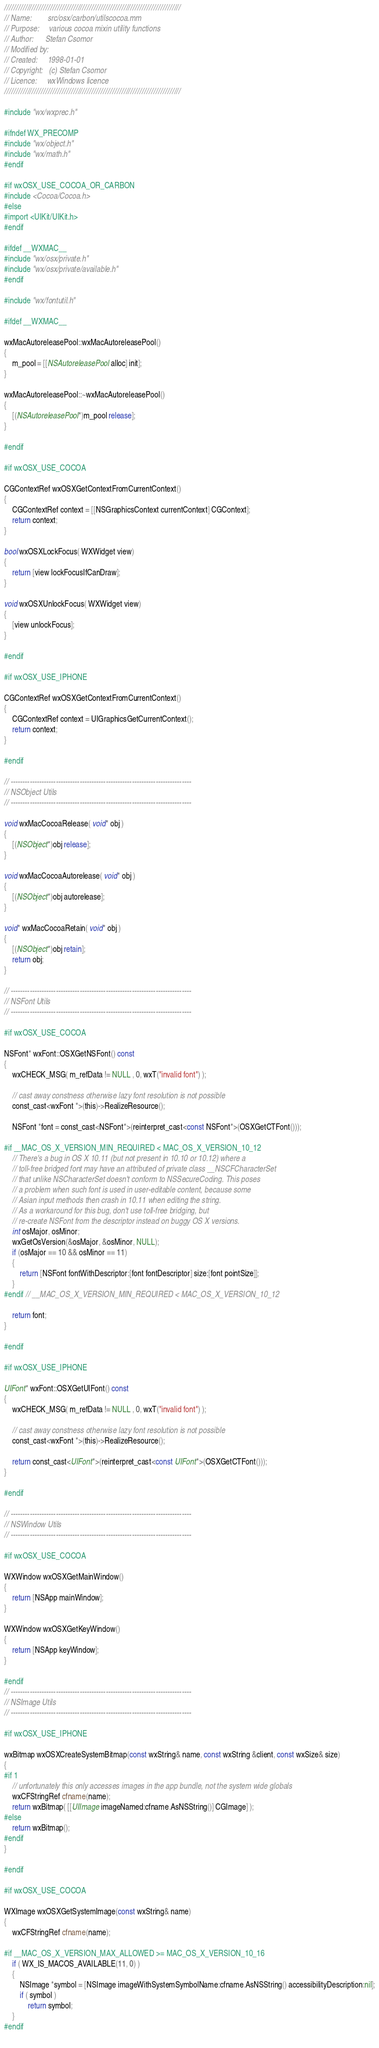<code> <loc_0><loc_0><loc_500><loc_500><_ObjectiveC_>/////////////////////////////////////////////////////////////////////////////
// Name:        src/osx/carbon/utilscocoa.mm
// Purpose:     various cocoa mixin utility functions
// Author:      Stefan Csomor
// Modified by:
// Created:     1998-01-01
// Copyright:   (c) Stefan Csomor
// Licence:     wxWindows licence
/////////////////////////////////////////////////////////////////////////////

#include "wx/wxprec.h"

#ifndef WX_PRECOMP
#include "wx/object.h"
#include "wx/math.h"
#endif

#if wxOSX_USE_COCOA_OR_CARBON
#include <Cocoa/Cocoa.h>
#else
#import <UIKit/UIKit.h>
#endif

#ifdef __WXMAC__
#include "wx/osx/private.h"
#include "wx/osx/private/available.h"
#endif

#include "wx/fontutil.h"

#ifdef __WXMAC__

wxMacAutoreleasePool::wxMacAutoreleasePool()
{
    m_pool = [[NSAutoreleasePool alloc] init];
}

wxMacAutoreleasePool::~wxMacAutoreleasePool()
{
    [(NSAutoreleasePool*)m_pool release];
}

#endif

#if wxOSX_USE_COCOA

CGContextRef wxOSXGetContextFromCurrentContext()
{
    CGContextRef context = [[NSGraphicsContext currentContext] CGContext];
    return context;
}

bool wxOSXLockFocus( WXWidget view)
{
    return [view lockFocusIfCanDraw];
}

void wxOSXUnlockFocus( WXWidget view)
{
    [view unlockFocus];
}

#endif

#if wxOSX_USE_IPHONE

CGContextRef wxOSXGetContextFromCurrentContext()
{
    CGContextRef context = UIGraphicsGetCurrentContext();
    return context;
}

#endif

// ----------------------------------------------------------------------------
// NSObject Utils
// ----------------------------------------------------------------------------

void wxMacCocoaRelease( void* obj )
{
    [(NSObject*)obj release];
}

void wxMacCocoaAutorelease( void* obj )
{
    [(NSObject*)obj autorelease];
}

void* wxMacCocoaRetain( void* obj )
{
    [(NSObject*)obj retain];
    return obj;
}

// ----------------------------------------------------------------------------
// NSFont Utils
// ----------------------------------------------------------------------------

#if wxOSX_USE_COCOA

NSFont* wxFont::OSXGetNSFont() const
{
    wxCHECK_MSG( m_refData != NULL , 0, wxT("invalid font") );

    // cast away constness otherwise lazy font resolution is not possible
    const_cast<wxFont *>(this)->RealizeResource();

    NSFont *font = const_cast<NSFont*>(reinterpret_cast<const NSFont*>(OSXGetCTFont()));

#if __MAC_OS_X_VERSION_MIN_REQUIRED < MAC_OS_X_VERSION_10_12
    // There's a bug in OS X 10.11 (but not present in 10.10 or 10.12) where a
    // toll-free bridged font may have an attributed of private class __NSCFCharacterSet
    // that unlike NSCharacterSet doesn't conform to NSSecureCoding. This poses
    // a problem when such font is used in user-editable content, because some
    // Asian input methods then crash in 10.11 when editing the string.
    // As a workaround for this bug, don't use toll-free bridging, but
    // re-create NSFont from the descriptor instead on buggy OS X versions.
    int osMajor, osMinor;
    wxGetOsVersion(&osMajor, &osMinor, NULL);
    if (osMajor == 10 && osMinor == 11)
    {
        return [NSFont fontWithDescriptor:[font fontDescriptor] size:[font pointSize]];
    }
#endif // __MAC_OS_X_VERSION_MIN_REQUIRED < MAC_OS_X_VERSION_10_12

    return font;
}

#endif

#if wxOSX_USE_IPHONE

UIFont* wxFont::OSXGetUIFont() const
{
    wxCHECK_MSG( m_refData != NULL , 0, wxT("invalid font") );

    // cast away constness otherwise lazy font resolution is not possible
    const_cast<wxFont *>(this)->RealizeResource();

    return const_cast<UIFont*>(reinterpret_cast<const UIFont*>(OSXGetCTFont()));
}

#endif

// ----------------------------------------------------------------------------
// NSWindow Utils
// ----------------------------------------------------------------------------

#if wxOSX_USE_COCOA

WXWindow wxOSXGetMainWindow()
{
    return [NSApp mainWindow];
}

WXWindow wxOSXGetKeyWindow()
{
    return [NSApp keyWindow];
}

#endif
// ----------------------------------------------------------------------------
// NSImage Utils
// ----------------------------------------------------------------------------

#if wxOSX_USE_IPHONE

wxBitmap wxOSXCreateSystemBitmap(const wxString& name, const wxString &client, const wxSize& size)
{
#if 1
    // unfortunately this only accesses images in the app bundle, not the system wide globals
    wxCFStringRef cfname(name);
    return wxBitmap( [[UIImage imageNamed:cfname.AsNSString()] CGImage] );
#else
    return wxBitmap();
#endif
}

#endif

#if wxOSX_USE_COCOA

WXImage wxOSXGetSystemImage(const wxString& name)
{
    wxCFStringRef cfname(name);

#if __MAC_OS_X_VERSION_MAX_ALLOWED >= MAC_OS_X_VERSION_10_16
    if ( WX_IS_MACOS_AVAILABLE(11, 0) )
    {
        NSImage *symbol = [NSImage imageWithSystemSymbolName:cfname.AsNSString() accessibilityDescription:nil];
        if ( symbol )
            return symbol;
    }
#endif
    </code> 